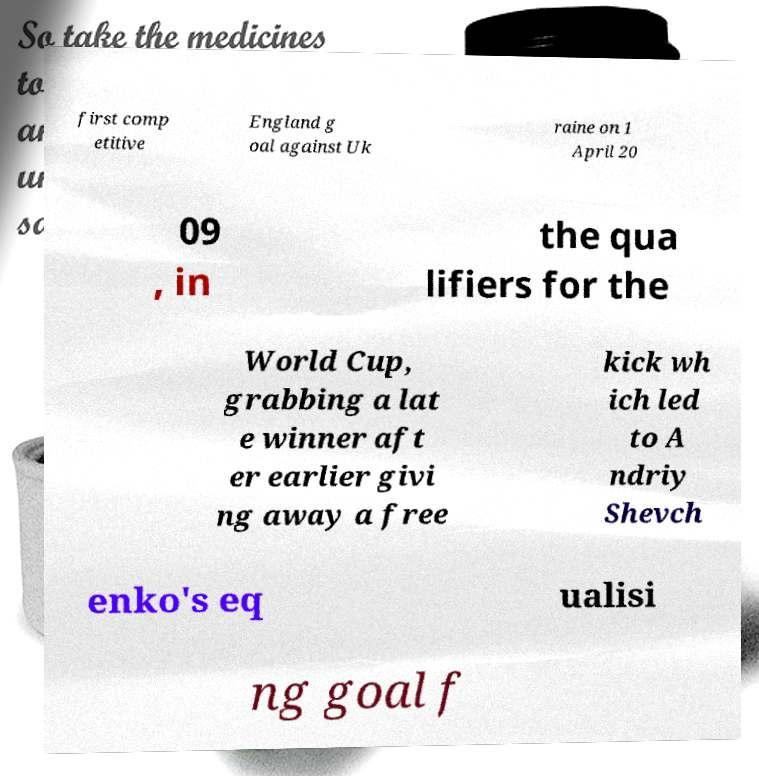Can you read and provide the text displayed in the image?This photo seems to have some interesting text. Can you extract and type it out for me? first comp etitive England g oal against Uk raine on 1 April 20 09 , in the qua lifiers for the World Cup, grabbing a lat e winner aft er earlier givi ng away a free kick wh ich led to A ndriy Shevch enko's eq ualisi ng goal f 